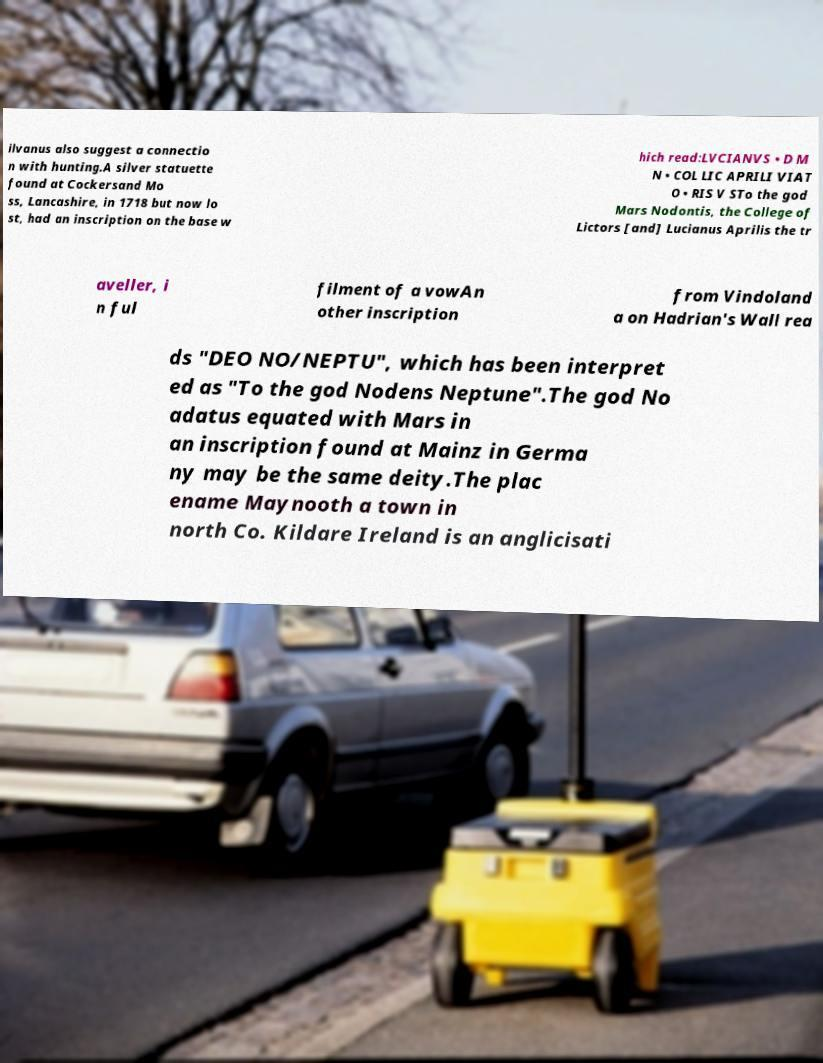Could you assist in decoding the text presented in this image and type it out clearly? ilvanus also suggest a connectio n with hunting.A silver statuette found at Cockersand Mo ss, Lancashire, in 1718 but now lo st, had an inscription on the base w hich read:LVCIANVS • D M N • COL LIC APRILI VIAT O • RIS V STo the god Mars Nodontis, the College of Lictors [and] Lucianus Aprilis the tr aveller, i n ful filment of a vowAn other inscription from Vindoland a on Hadrian's Wall rea ds "DEO NO/NEPTU", which has been interpret ed as "To the god Nodens Neptune".The god No adatus equated with Mars in an inscription found at Mainz in Germa ny may be the same deity.The plac ename Maynooth a town in north Co. Kildare Ireland is an anglicisati 